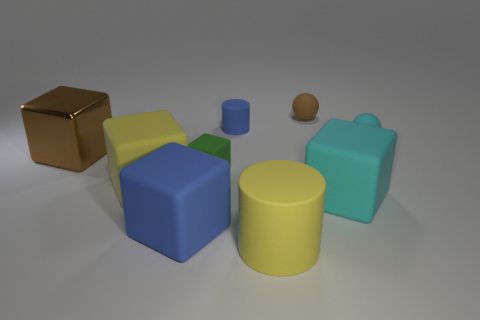Subtract all green matte cubes. How many cubes are left? 4 Add 1 big metal cylinders. How many objects exist? 10 Subtract all yellow blocks. How many blocks are left? 4 Subtract all cylinders. How many objects are left? 7 Subtract 3 cubes. How many cubes are left? 2 Subtract 1 cyan spheres. How many objects are left? 8 Subtract all gray cylinders. Subtract all blue balls. How many cylinders are left? 2 Subtract all large brown rubber blocks. Subtract all big yellow cubes. How many objects are left? 8 Add 5 large yellow rubber objects. How many large yellow rubber objects are left? 7 Add 2 tiny cyan matte spheres. How many tiny cyan matte spheres exist? 3 